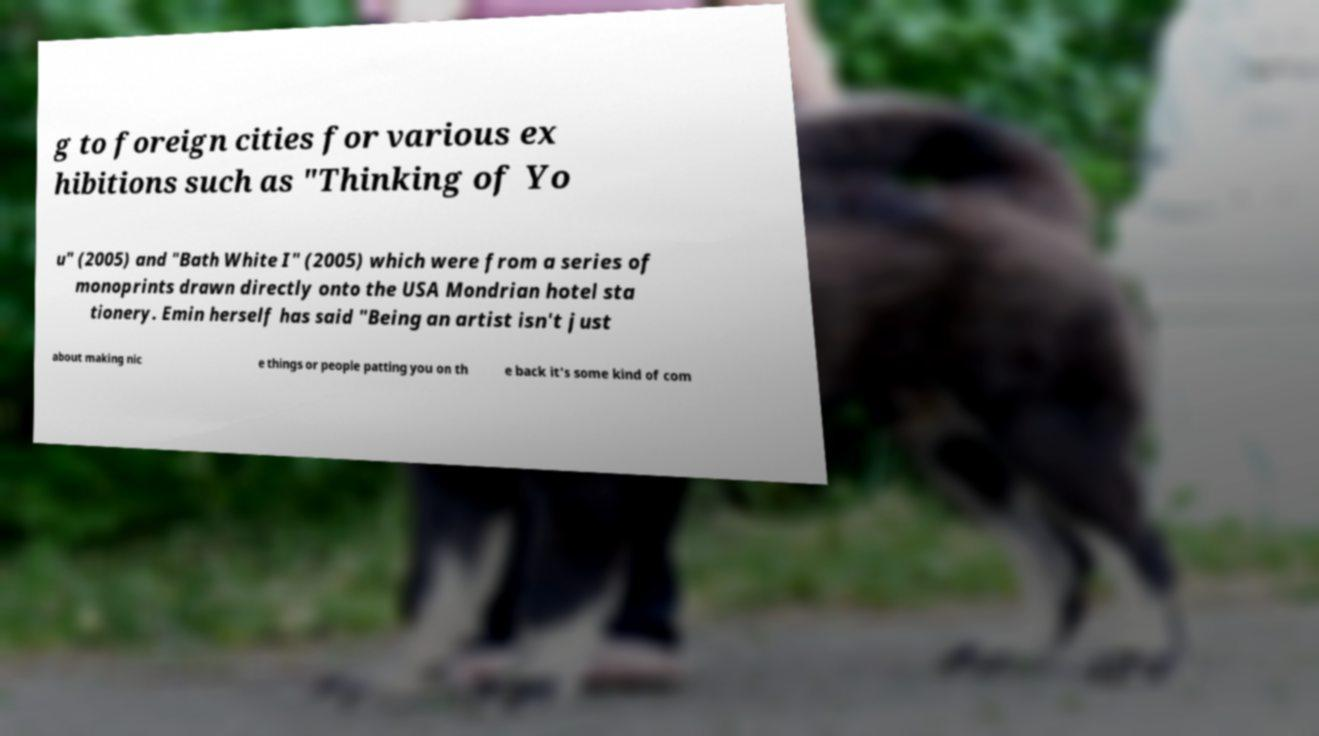For documentation purposes, I need the text within this image transcribed. Could you provide that? g to foreign cities for various ex hibitions such as "Thinking of Yo u" (2005) and "Bath White I" (2005) which were from a series of monoprints drawn directly onto the USA Mondrian hotel sta tionery. Emin herself has said "Being an artist isn't just about making nic e things or people patting you on th e back it's some kind of com 